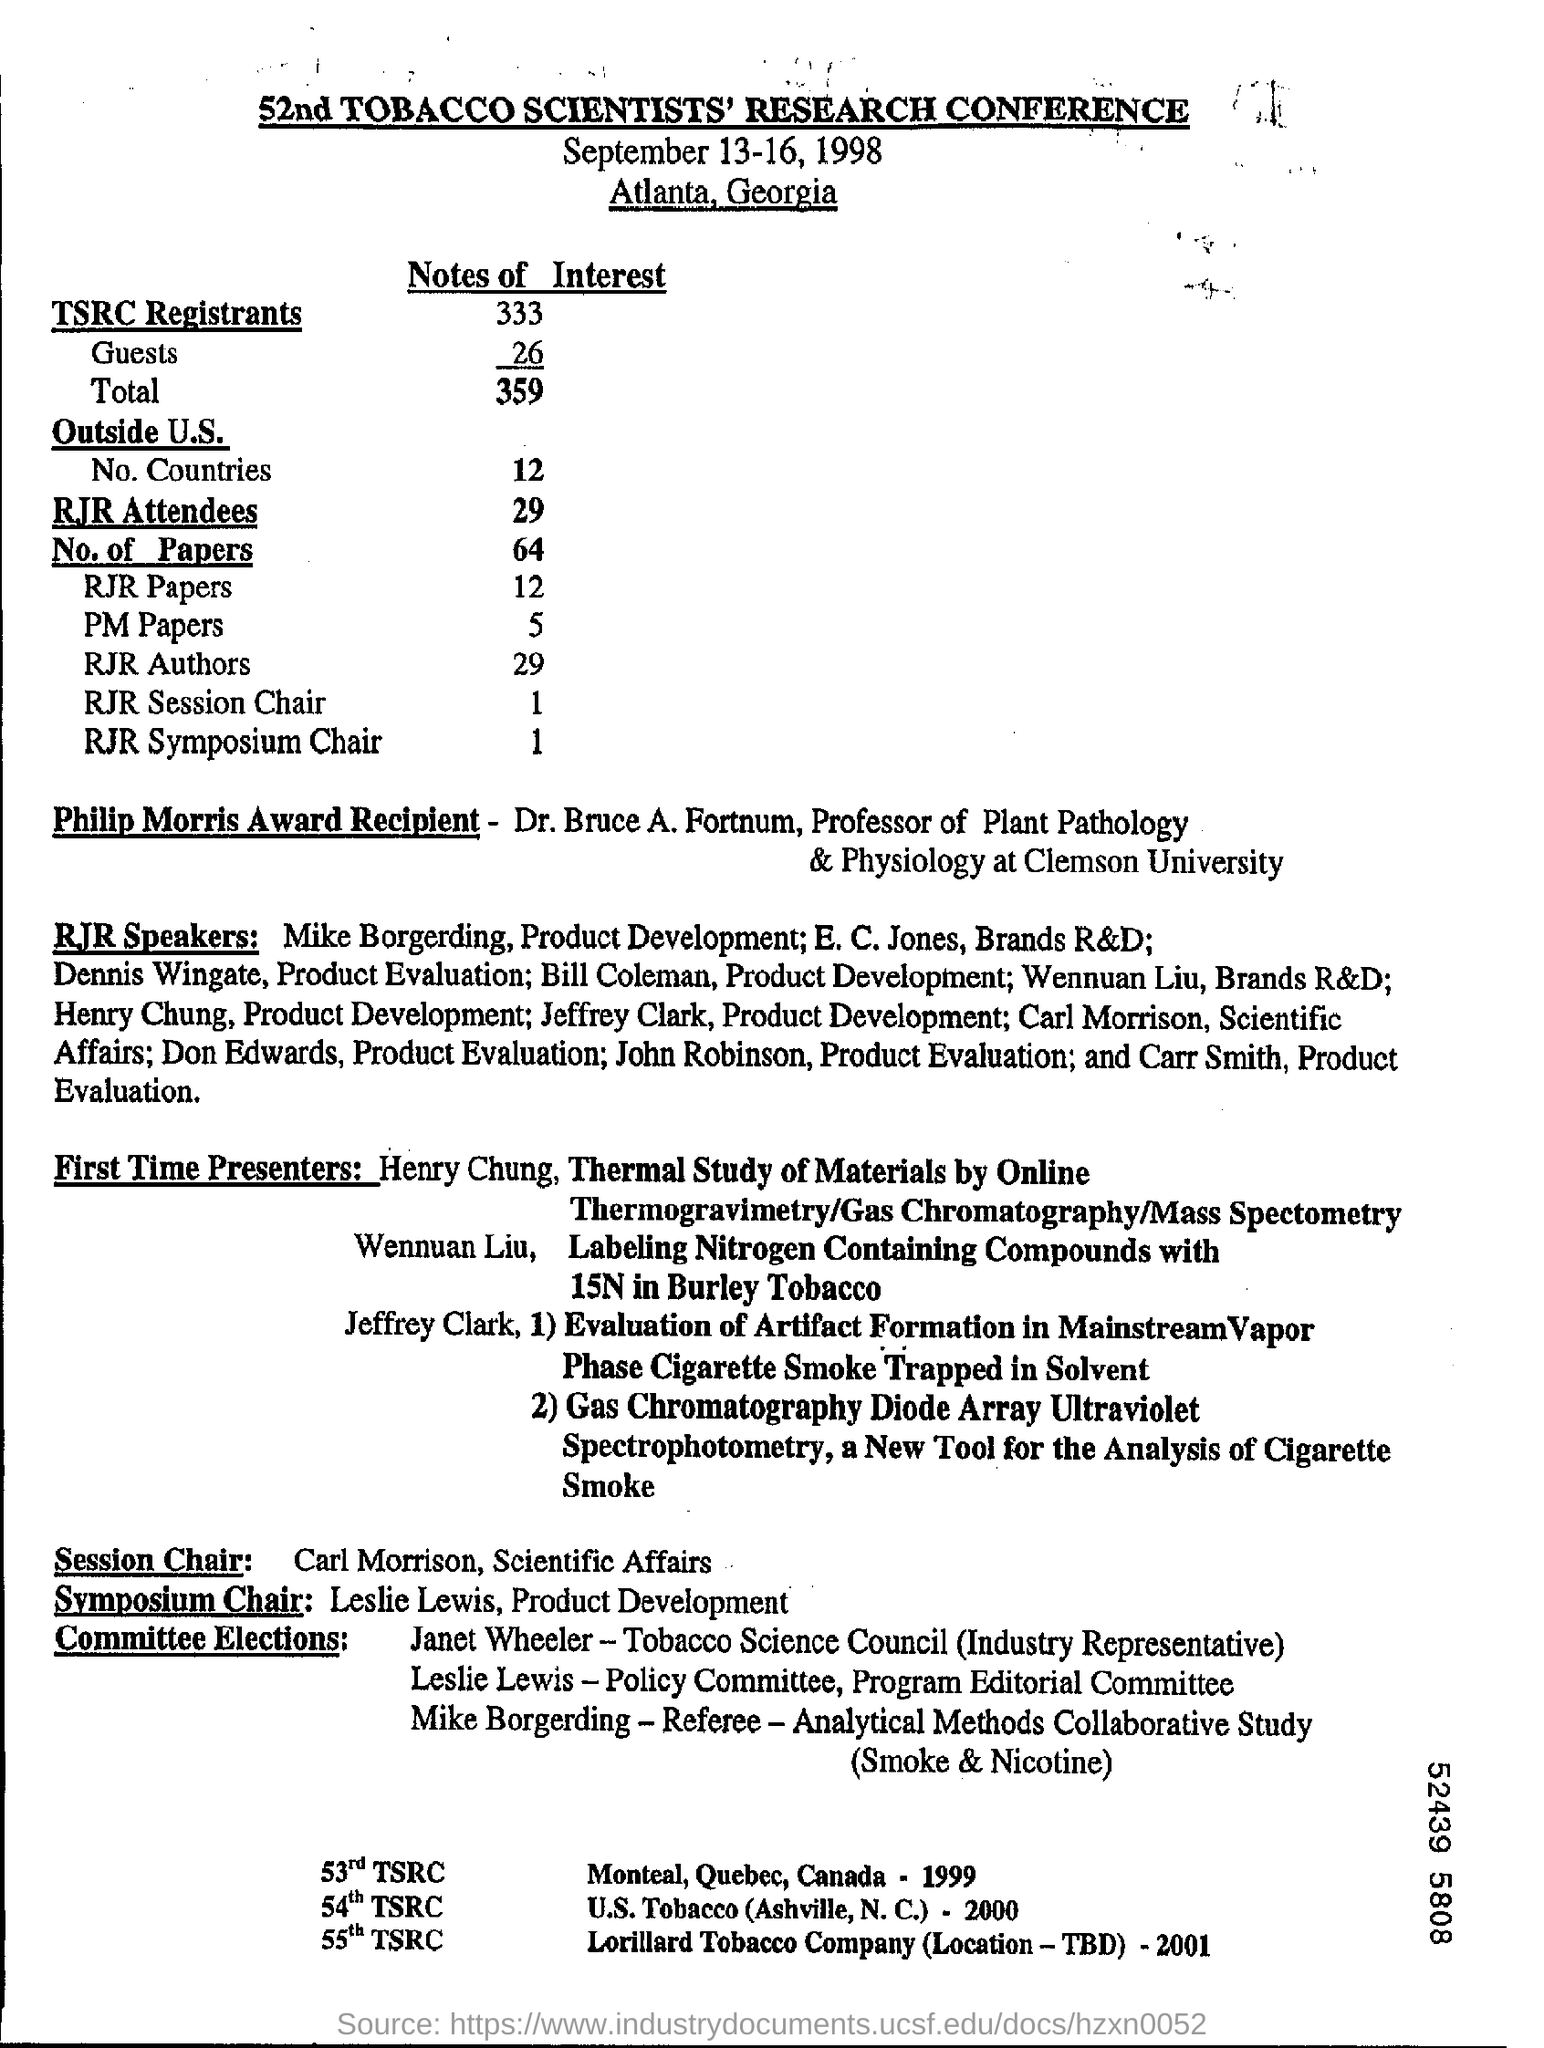Where was the conference was held in ?
Your response must be concise. Atlanta, Georgia. How many RJR attendees in the conference ?
Give a very brief answer. 29. What is the total number of tsrc registrants ?
Offer a very short reply. 359. 